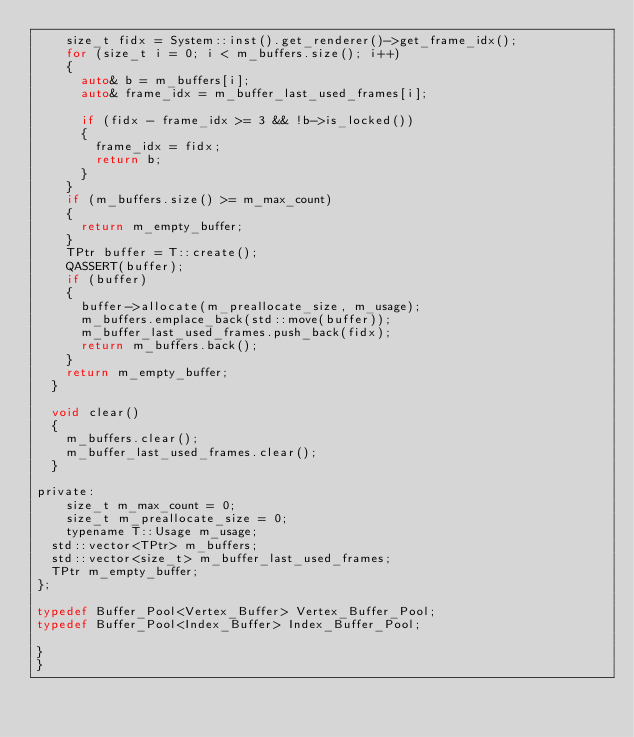Convert code to text. <code><loc_0><loc_0><loc_500><loc_500><_C_>		size_t fidx = System::inst().get_renderer()->get_frame_idx();
		for (size_t i = 0; i < m_buffers.size(); i++)
		{
			auto& b = m_buffers[i];
			auto& frame_idx = m_buffer_last_used_frames[i];

			if (fidx - frame_idx >= 3 && !b->is_locked())
			{
				frame_idx = fidx;
				return b;
			}
		}
		if (m_buffers.size() >= m_max_count)
		{
			return m_empty_buffer;
		}
		TPtr buffer = T::create();
		QASSERT(buffer);
		if (buffer)
		{
			buffer->allocate(m_preallocate_size, m_usage);
			m_buffers.emplace_back(std::move(buffer));
			m_buffer_last_used_frames.push_back(fidx);
			return m_buffers.back();
		}
		return m_empty_buffer;
	}

	void clear()
	{
		m_buffers.clear();
		m_buffer_last_used_frames.clear();
	}

private:
    size_t m_max_count = 0;
    size_t m_preallocate_size = 0;
    typename T::Usage m_usage;
	std::vector<TPtr> m_buffers;
	std::vector<size_t> m_buffer_last_used_frames;
	TPtr m_empty_buffer;
};

typedef Buffer_Pool<Vertex_Buffer> Vertex_Buffer_Pool;
typedef Buffer_Pool<Index_Buffer> Index_Buffer_Pool;

}
}
</code> 